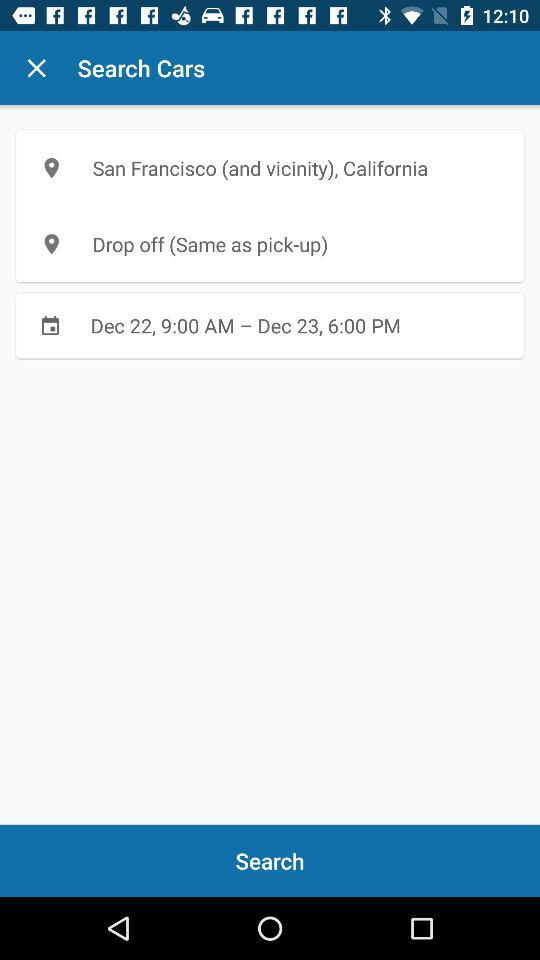Which location is the same as the pick-up location? The location that is the same as the pick-up location is drop off. 